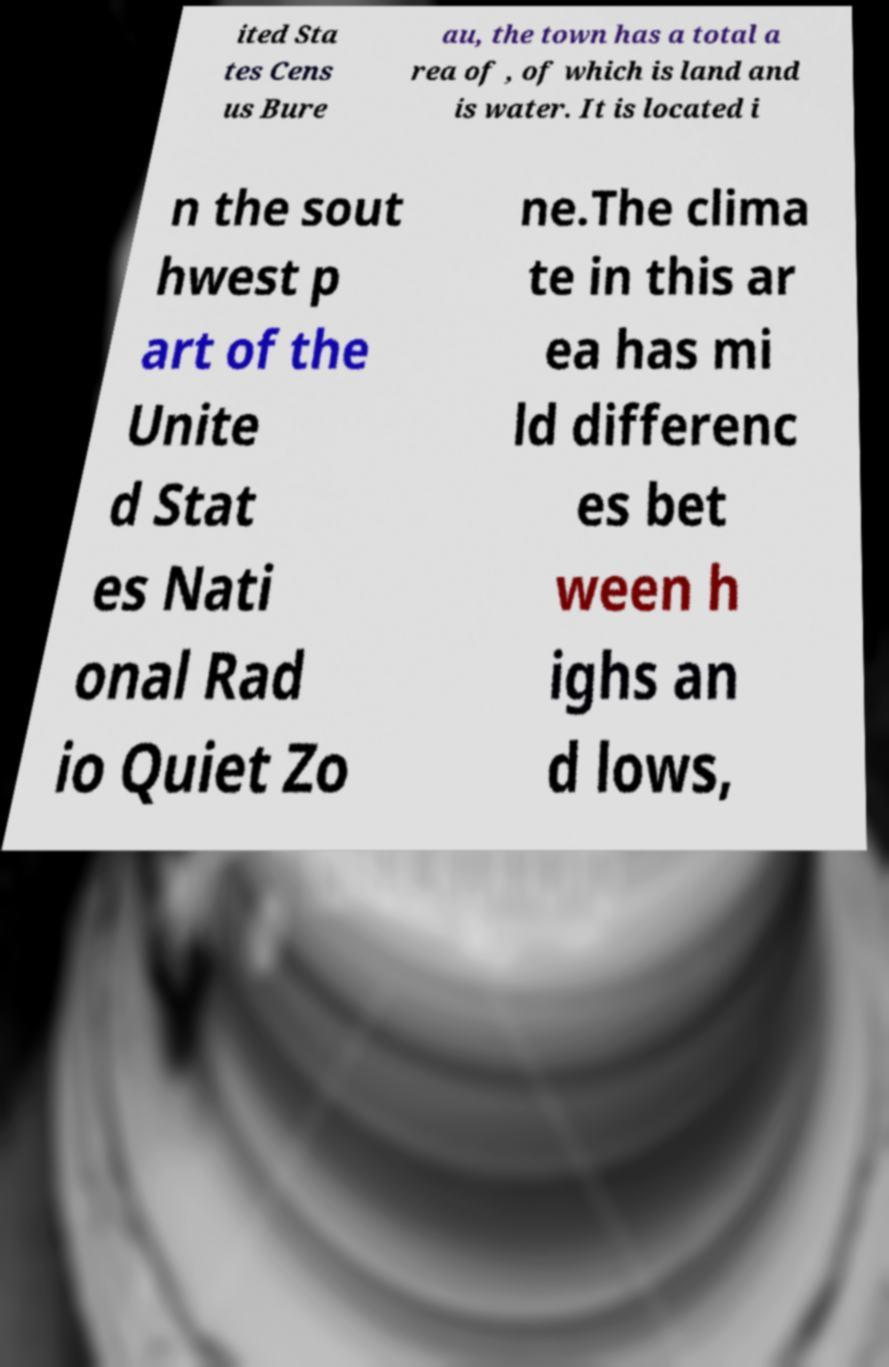I need the written content from this picture converted into text. Can you do that? ited Sta tes Cens us Bure au, the town has a total a rea of , of which is land and is water. It is located i n the sout hwest p art of the Unite d Stat es Nati onal Rad io Quiet Zo ne.The clima te in this ar ea has mi ld differenc es bet ween h ighs an d lows, 